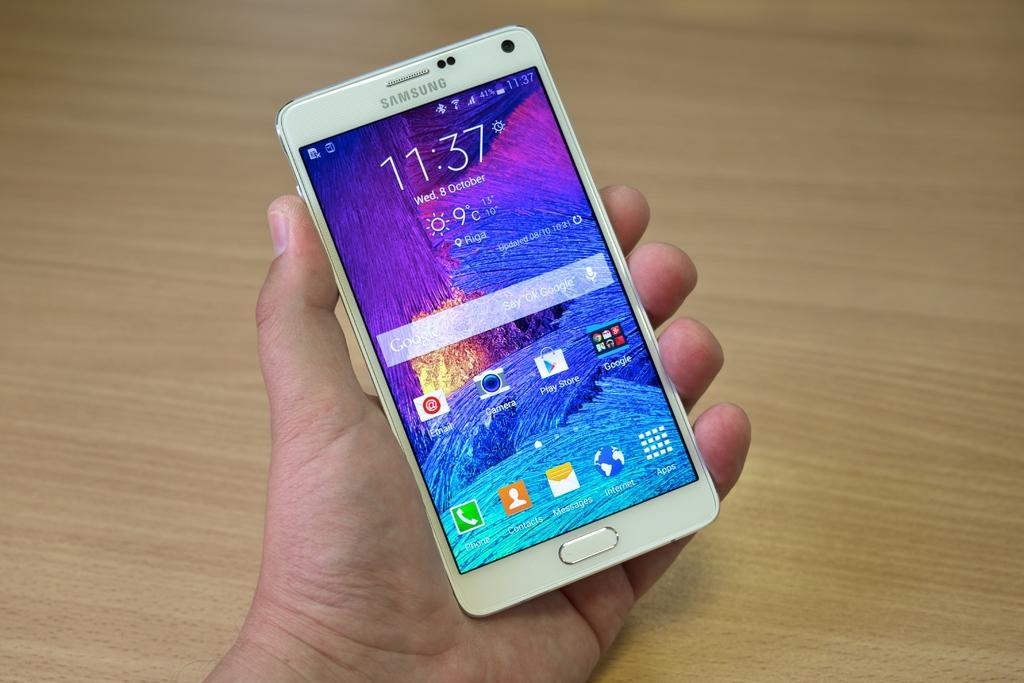<image>
Describe the image concisely. A hand holds a Samsung smartphone on Wed 8 October at 11:37. 